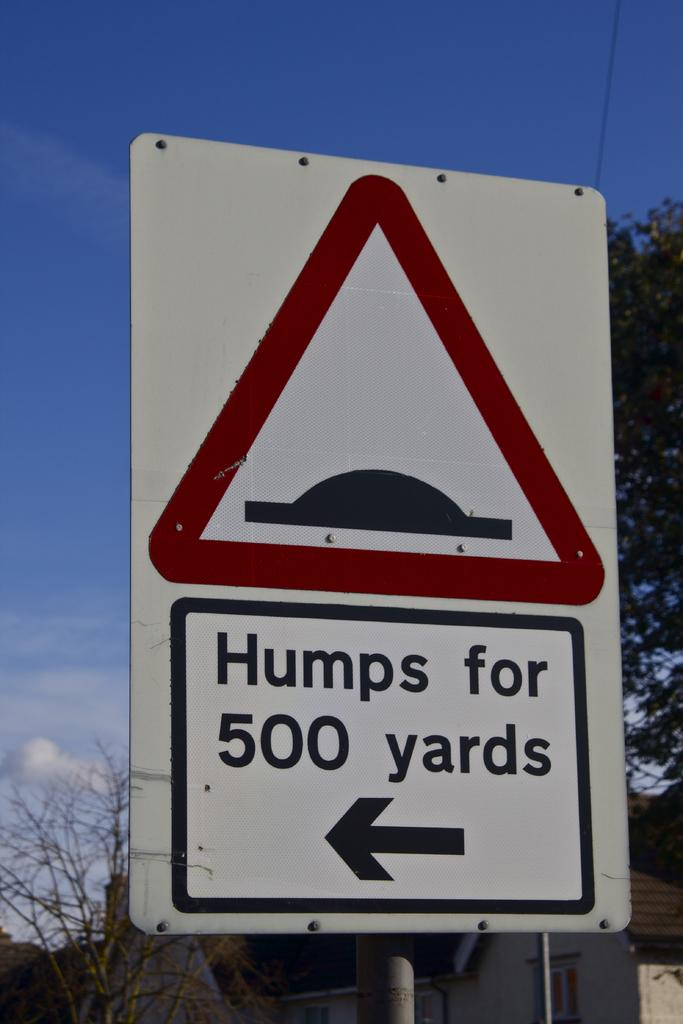Provide a one-sentence caption for the provided image. The sign indicates that there are humps for the next 500 yards. 